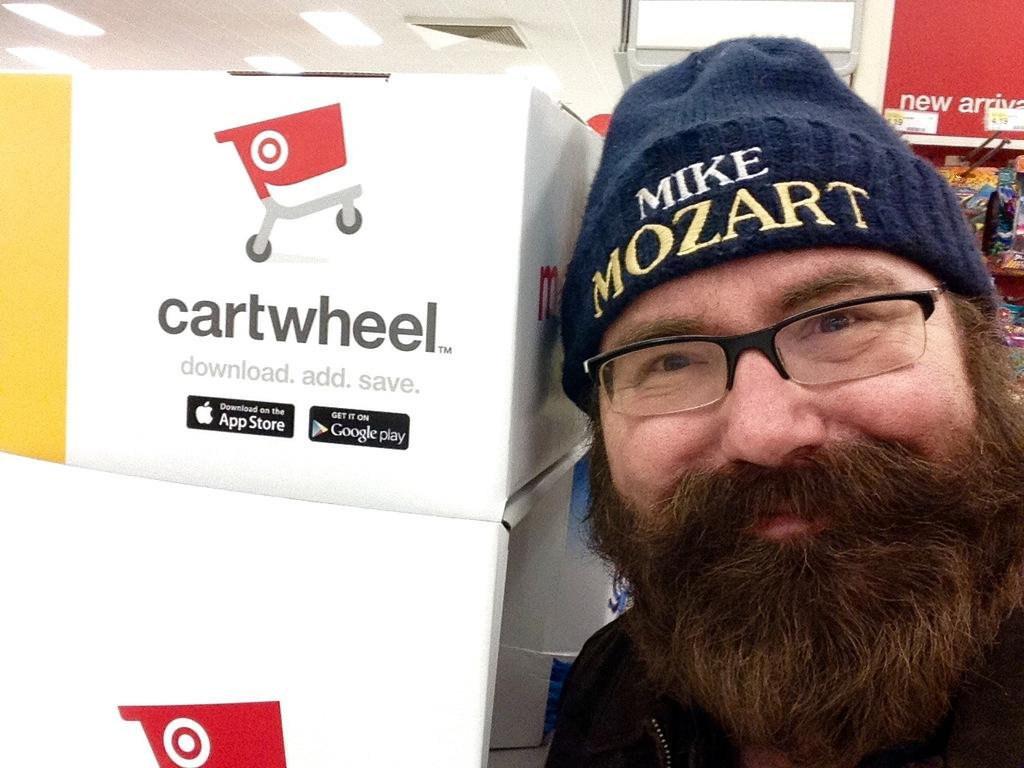Who or what is present in the image? There is a person in the image. What is located beside the person? There is a box with text on it beside the person. What can be seen in the background of the image? There are objects in the background of the image. What type of lighting is present in the image? Lights are attached to the ceiling in the image. How does the person in the image organize the ball? There is no ball present in the image, so it is not possible to discuss how the person organizes it. 